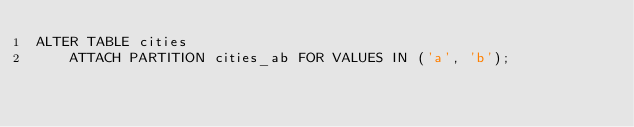Convert code to text. <code><loc_0><loc_0><loc_500><loc_500><_SQL_>ALTER TABLE cities
    ATTACH PARTITION cities_ab FOR VALUES IN ('a', 'b');
</code> 